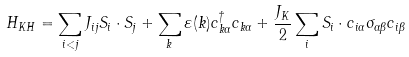Convert formula to latex. <formula><loc_0><loc_0><loc_500><loc_500>H _ { K H } = \sum _ { i < j } J _ { i j } { S } _ { i } \cdot { S } _ { j } + \sum _ { k } \varepsilon ( k ) c _ { k \alpha } ^ { \dagger } c _ { k \alpha } + \frac { J _ { K } } { 2 } \sum _ { i } { S } _ { i } \cdot c _ { i \alpha } { \sigma } _ { \alpha \beta } c _ { i \beta }</formula> 